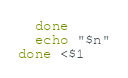Convert code to text. <code><loc_0><loc_0><loc_500><loc_500><_Bash_>  done
  echo "$n"
done <$1
</code> 